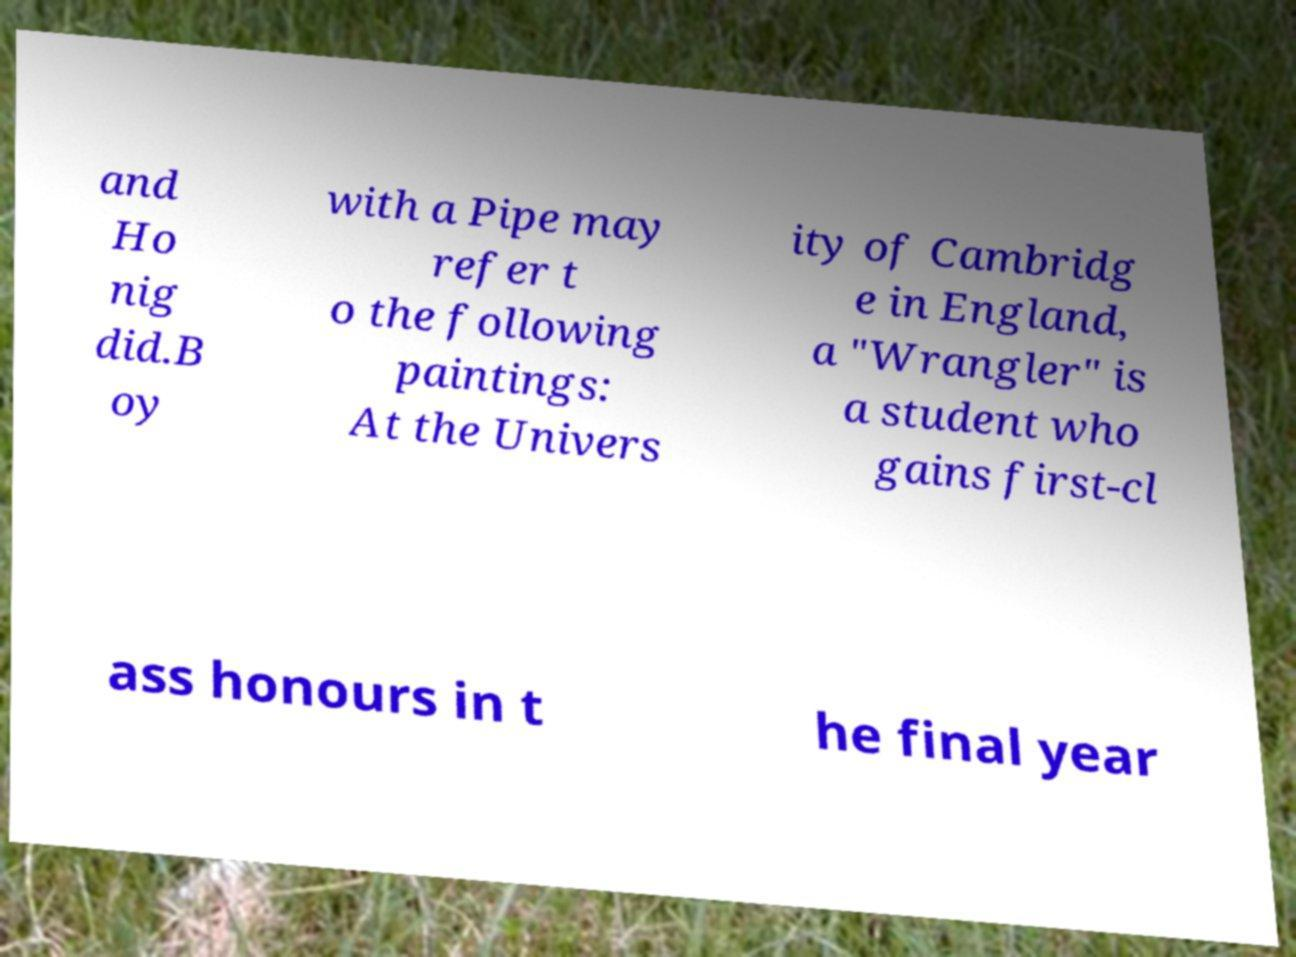Can you accurately transcribe the text from the provided image for me? and Ho nig did.B oy with a Pipe may refer t o the following paintings: At the Univers ity of Cambridg e in England, a "Wrangler" is a student who gains first-cl ass honours in t he final year 